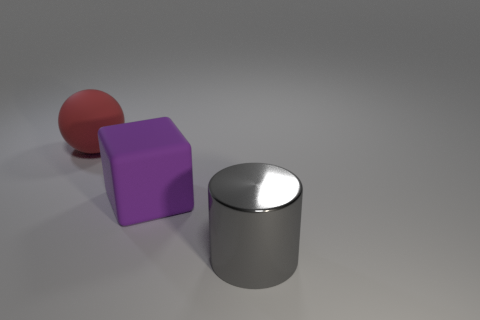What materials do the objects in this image appear to be made of? The objects in the image appear to be made of materials that one typically associates with modern industrial design. The ball has a matte finish that suggests it could be made of rubber, the block looks to have a plastic-like surface, and the cylinder has a reflective metal finish. 